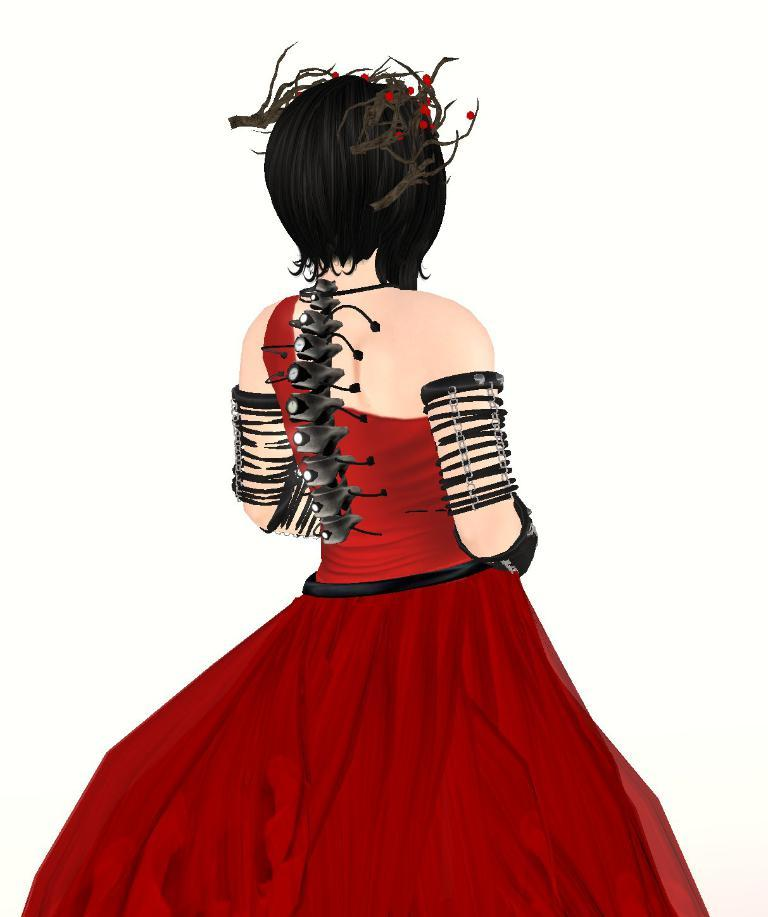Who or what is the main subject in the image? There is a person in the image. What is the person wearing? The person is wearing a dress. Can you describe the dress? The dress is in red and black color. What accessory is the person wearing on their head? The person is wearing a crown. What is the color of the background in the image? The background of the image is white. What type of scent can be detected from the person in the image? There is no information about any scent in the image, so it cannot be determined. 